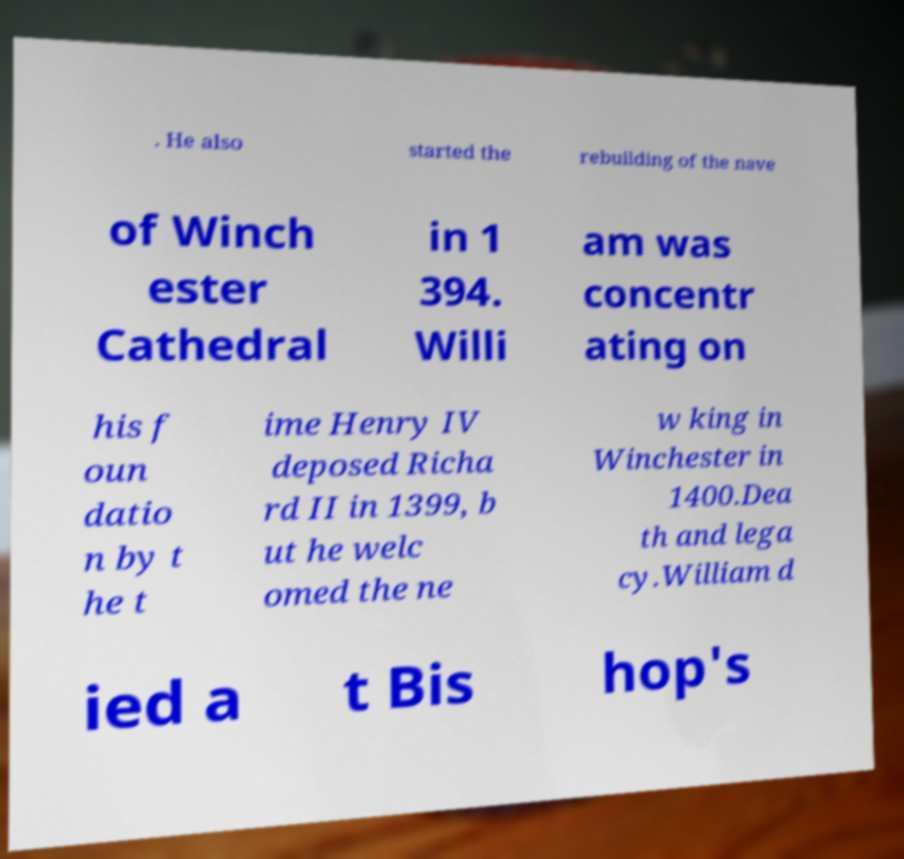Could you extract and type out the text from this image? . He also started the rebuilding of the nave of Winch ester Cathedral in 1 394. Willi am was concentr ating on his f oun datio n by t he t ime Henry IV deposed Richa rd II in 1399, b ut he welc omed the ne w king in Winchester in 1400.Dea th and lega cy.William d ied a t Bis hop's 